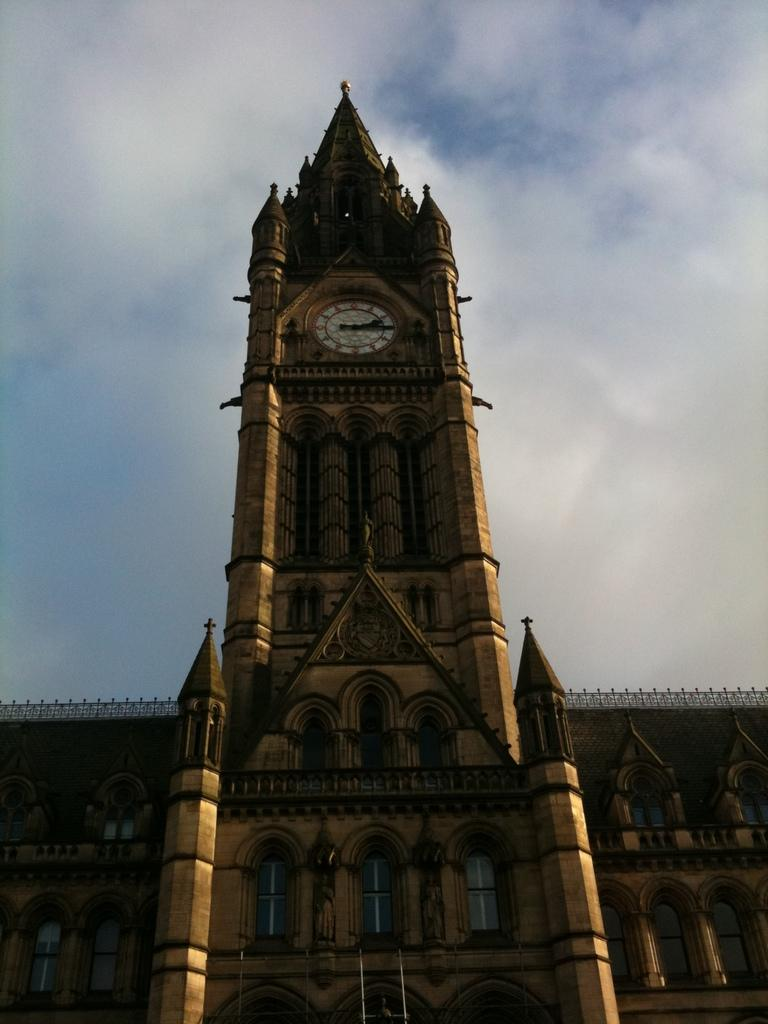What is the main structure in the image? There is a clock tower in the image. What other architectural feature can be seen in the image? There is a building in the image. What part of the building is visible in the image? Windows and pillars are visible in the image. What is visible in the background of the image? The sky is visible in the image, and clouds are present in the sky. What type of card is being played by the team in the image? There is no team or card present in the image; it features a clock tower, a building, and other architectural elements. 